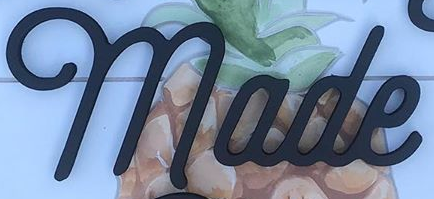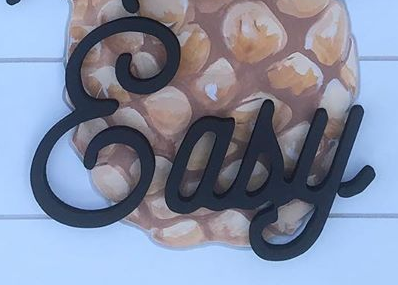What text is displayed in these images sequentially, separated by a semicolon? made; &asy 